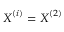Convert formula to latex. <formula><loc_0><loc_0><loc_500><loc_500>X ^ { ( i ) } = X ^ { ( 2 ) }</formula> 